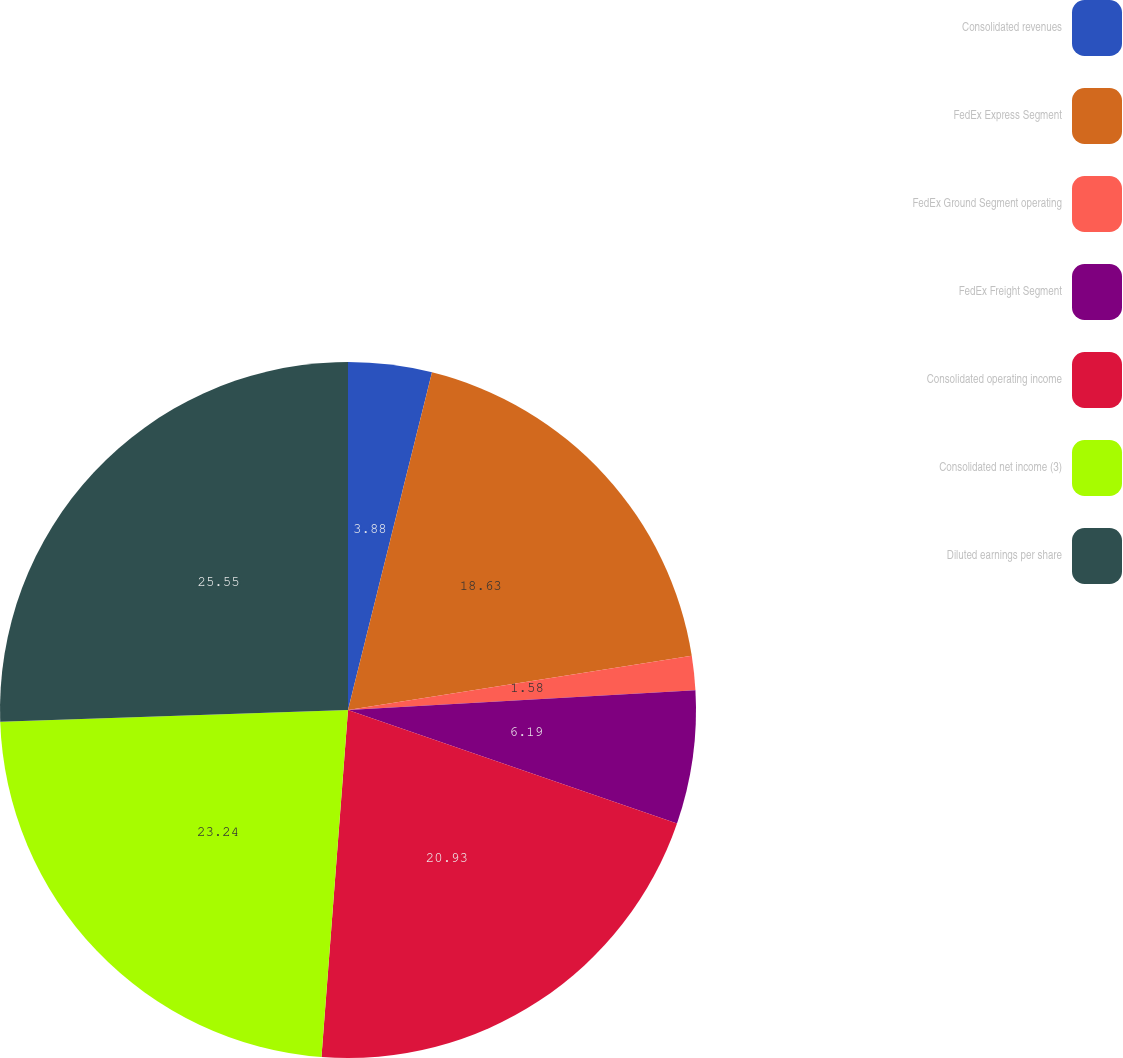Convert chart to OTSL. <chart><loc_0><loc_0><loc_500><loc_500><pie_chart><fcel>Consolidated revenues<fcel>FedEx Express Segment<fcel>FedEx Ground Segment operating<fcel>FedEx Freight Segment<fcel>Consolidated operating income<fcel>Consolidated net income (3)<fcel>Diluted earnings per share<nl><fcel>3.88%<fcel>18.63%<fcel>1.58%<fcel>6.19%<fcel>20.93%<fcel>23.24%<fcel>25.54%<nl></chart> 